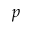Convert formula to latex. <formula><loc_0><loc_0><loc_500><loc_500>p</formula> 